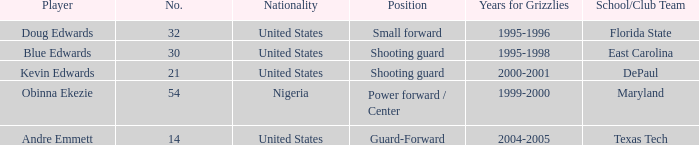What's the highest player number from the list from 2000-2001 21.0. 